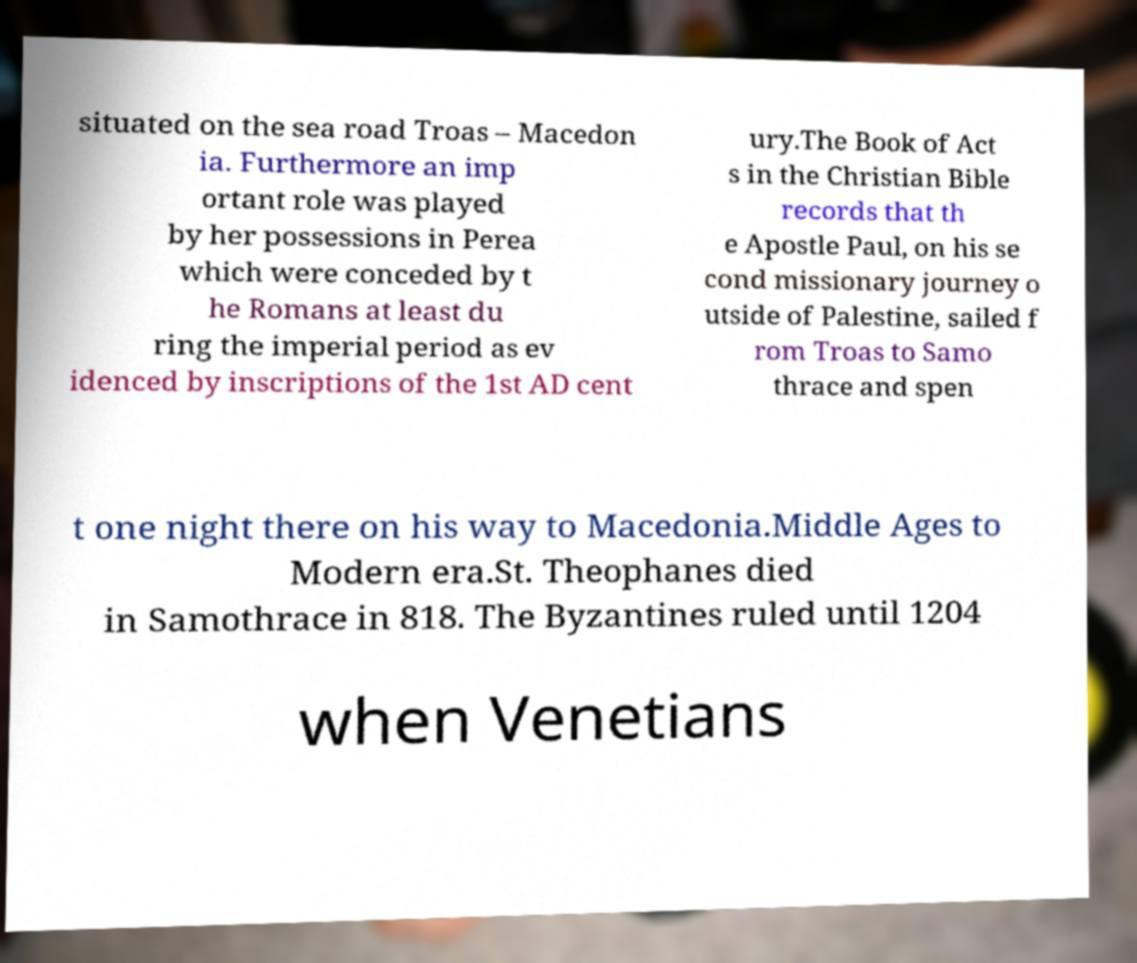Can you accurately transcribe the text from the provided image for me? situated on the sea road Troas – Macedon ia. Furthermore an imp ortant role was played by her possessions in Perea which were conceded by t he Romans at least du ring the imperial period as ev idenced by inscriptions of the 1st AD cent ury.The Book of Act s in the Christian Bible records that th e Apostle Paul, on his se cond missionary journey o utside of Palestine, sailed f rom Troas to Samo thrace and spen t one night there on his way to Macedonia.Middle Ages to Modern era.St. Theophanes died in Samothrace in 818. The Byzantines ruled until 1204 when Venetians 